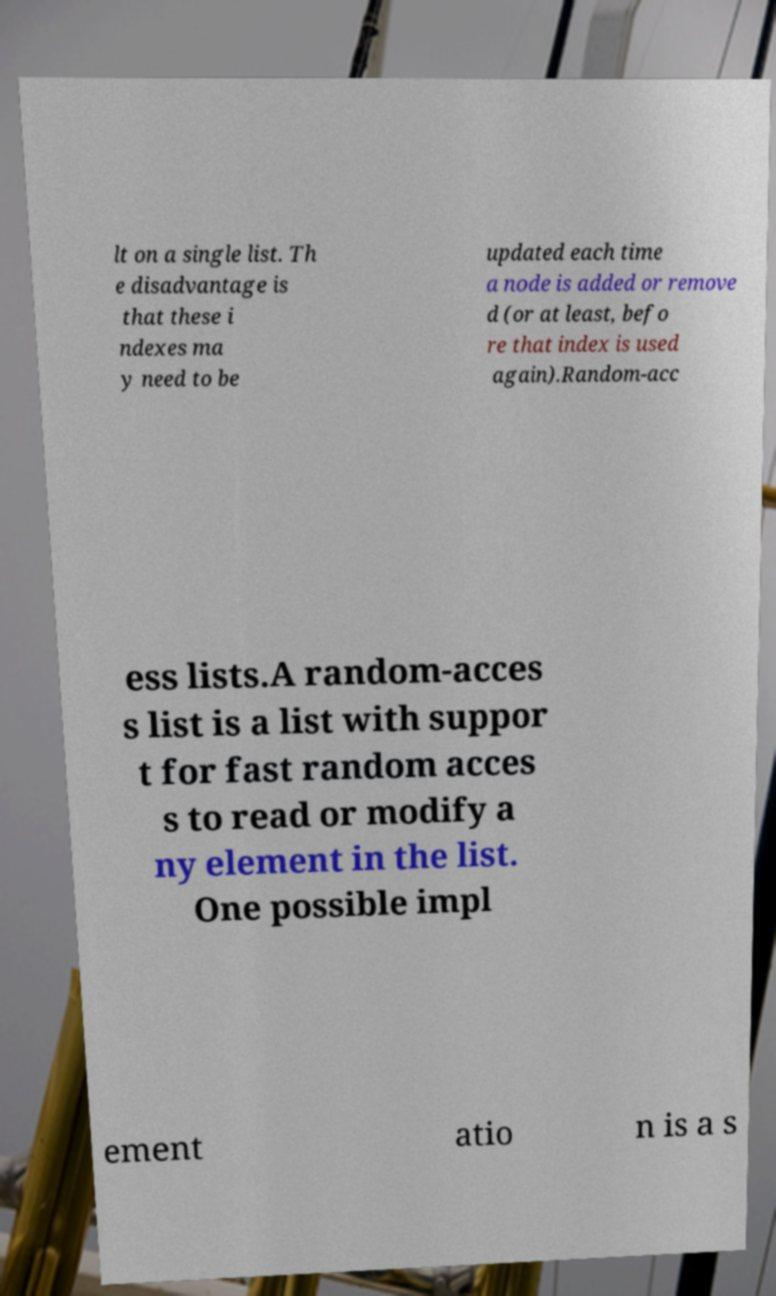I need the written content from this picture converted into text. Can you do that? lt on a single list. Th e disadvantage is that these i ndexes ma y need to be updated each time a node is added or remove d (or at least, befo re that index is used again).Random-acc ess lists.A random-acces s list is a list with suppor t for fast random acces s to read or modify a ny element in the list. One possible impl ement atio n is a s 